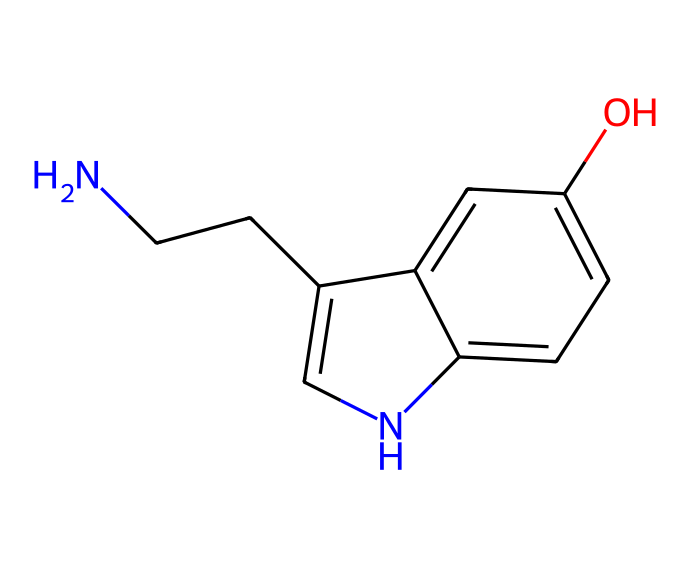What is the molecular formula of this chemical? The chemical has atoms of nitrogen (N), carbon (C), hydrogen (H), and oxygen (O). By counting the atoms in the structure represented by the SMILES notation, the molecular formula can be derived as C10H12N2O.
Answer: C10H12N2O How many aromatic rings are present in this structure? By analyzing the structure, we see that there are two interconnected carbon rings that are aromatic due to the alternating double bonds and planar structure containing nitrogen. This defines them as aromatic systems.
Answer: 2 What kind of functional group is present in this biochemical structure? The presence of the hydroxyl (-OH) group signifies that this biochemical has a phenolic functional group, which is characteristic of compounds that impact mood regulation.
Answer: hydroxyl Which atom in the structure is responsible for forming hydrogen bonds? The nitrogen atom and the oxygen atom both can participate in hydrogen bonding due to their electronegativity and lone pairs of electrons. The presence of -NH and -OH indicates potential hydrogen bond acceptors and donors.
Answer: nitrogen and oxygen Does this compound contain nitrogen? A straightforward examination of the SMILES representation reveals the presence of an 'N' in the structure, confirming that nitrogen is part of the molecule.
Answer: yes What is the role of this chemical in the human body? Based on the chemical structure and its attributes, serotonin functions primarily as a neurotransmitter that plays a critical role in mood regulation and influences various physiological processes.
Answer: mood regulation 